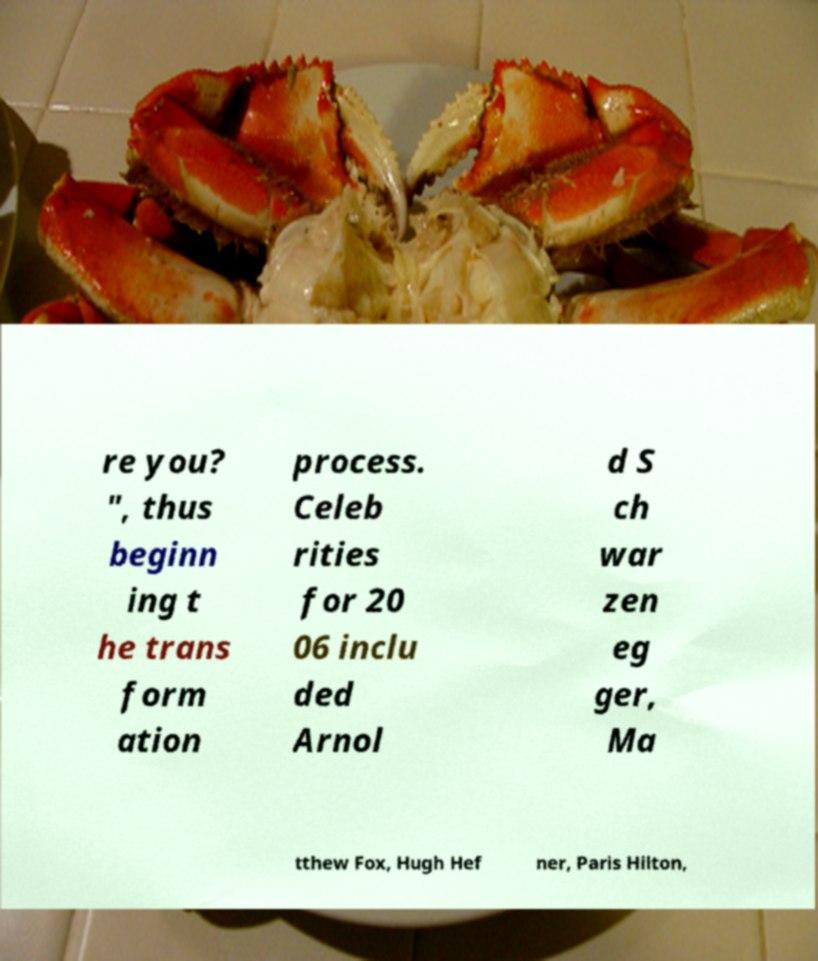Could you extract and type out the text from this image? re you? ", thus beginn ing t he trans form ation process. Celeb rities for 20 06 inclu ded Arnol d S ch war zen eg ger, Ma tthew Fox, Hugh Hef ner, Paris Hilton, 